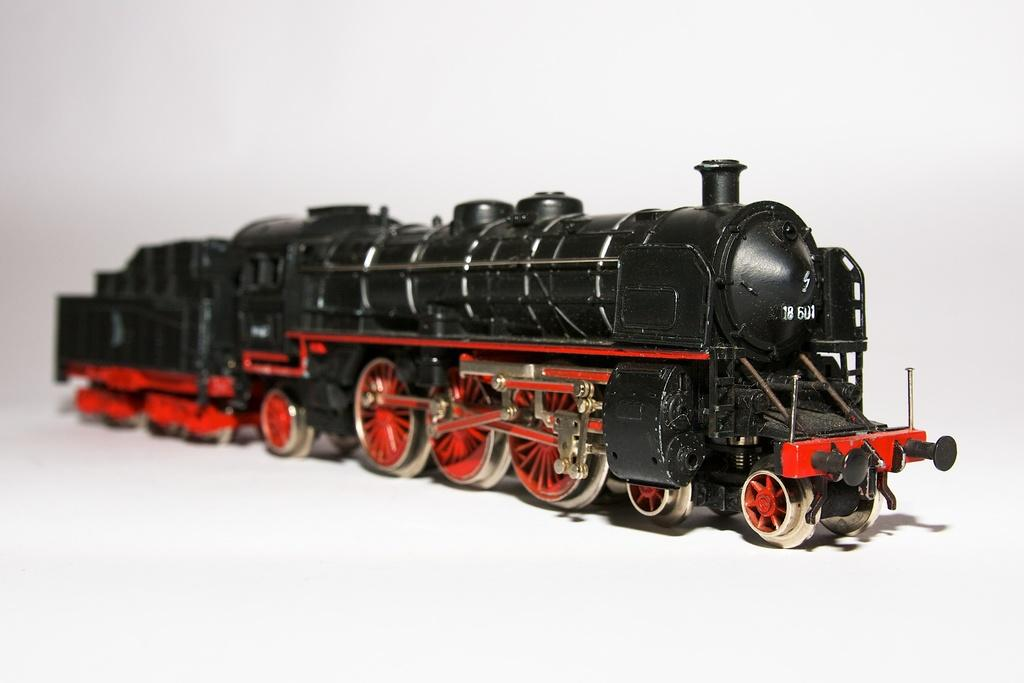What is the main subject of the image? The main subject of the image is a black color toy train. What color are the wheels of the toy train? The wheels of the toy train are orange in color. Where is the toy train located in the image? The toy train is on a surface in the image. What color is the background of the image? The background of the image is white in color. How many daughters are present in the image? There are no daughters present in the image; it features a toy train. What type of army is depicted in the image? There is no army depicted in the image; it features a toy train on a surface with a white background. 